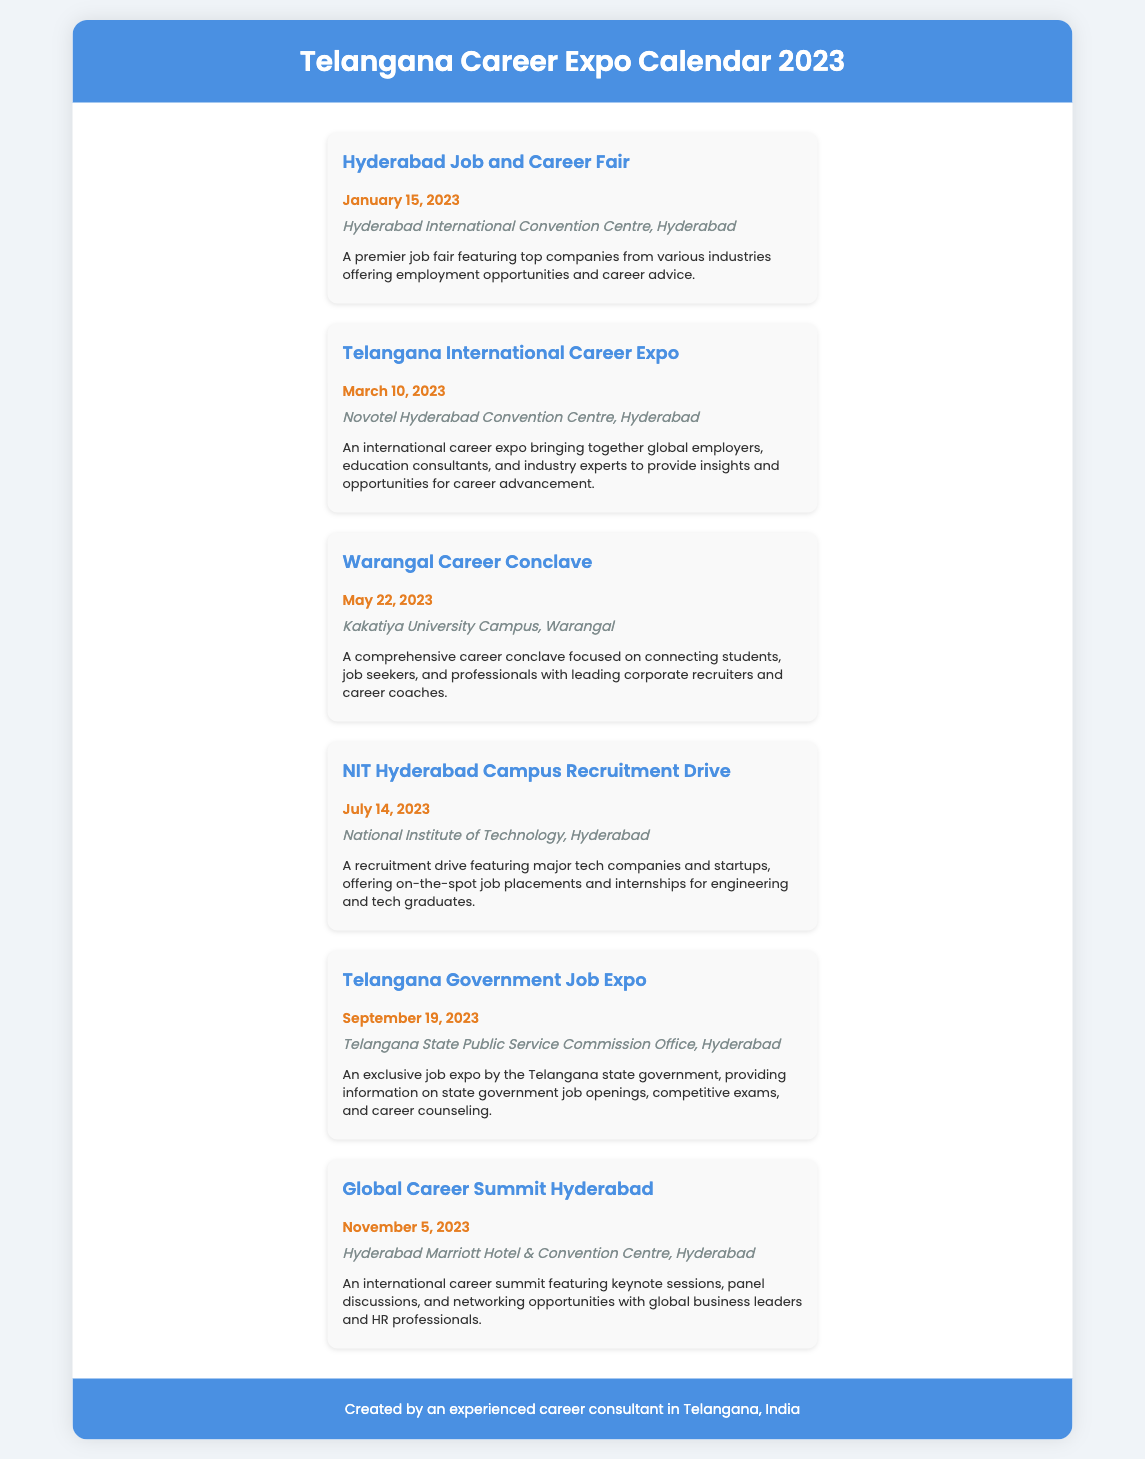What is the date of the Telangana International Career Expo? The date is listed in the event section of the document for the Telangana International Career Expo.
Answer: March 10, 2023 Where is the Hyderabad Job and Career Fair located? The location is mentioned in the event details for the Hyderabad Job and Career Fair.
Answer: Hyderabad International Convention Centre, Hyderabad Which event is scheduled for September 19, 2023? This requires locating the specific date in the document and identifying the associated event.
Answer: Telangana Government Job Expo How many career expos are held in Hyderabad? The document lists multiple events and requires counting those specifically held in Hyderabad.
Answer: Four What type of event is the Warangal Career Conclave? The nature of the event is described in its details, highlighting its purpose and audience.
Answer: Career conclave Which venue will host the Global Career Summit? The venue is specified in the details for the Global Career Summit within the document.
Answer: Hyderabad Marriott Hotel & Convention Centre, Hyderabad What is the focus of the NIT Hyderabad Campus Recruitment Drive? The focus is mentioned in the description of the NIT Hyderabad Campus Recruitment Drive, detailing the target audience.
Answer: Job placements and internships How many words are in the description for the Telangana Government Job Expo? This can be derived by counting the words in the description of the listed event.
Answer: 36 words 